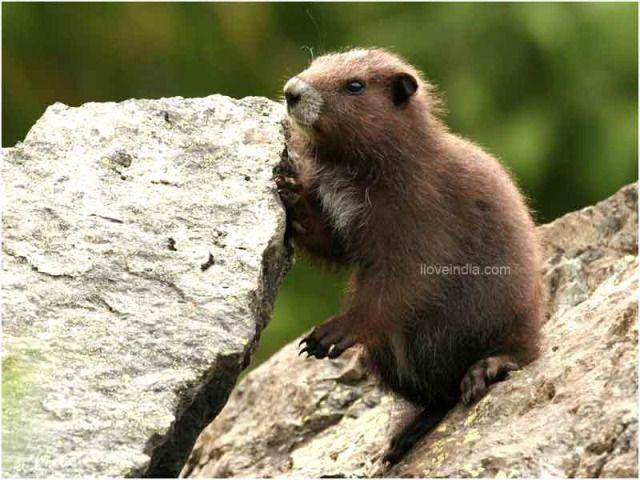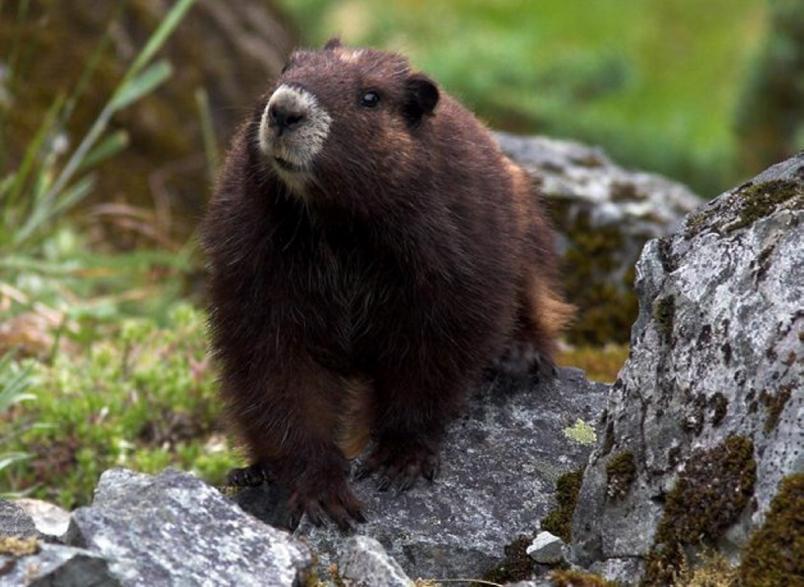The first image is the image on the left, the second image is the image on the right. Considering the images on both sides, is "The left and right image contains a total of three groundhogs." valid? Answer yes or no. No. The first image is the image on the left, the second image is the image on the right. Considering the images on both sides, is "One image contains twice as many marmots as the other image." valid? Answer yes or no. No. 